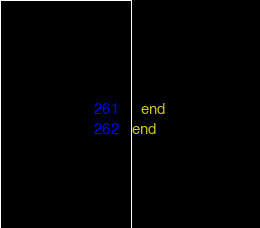<code> <loc_0><loc_0><loc_500><loc_500><_Elixir_>  end
end
</code> 